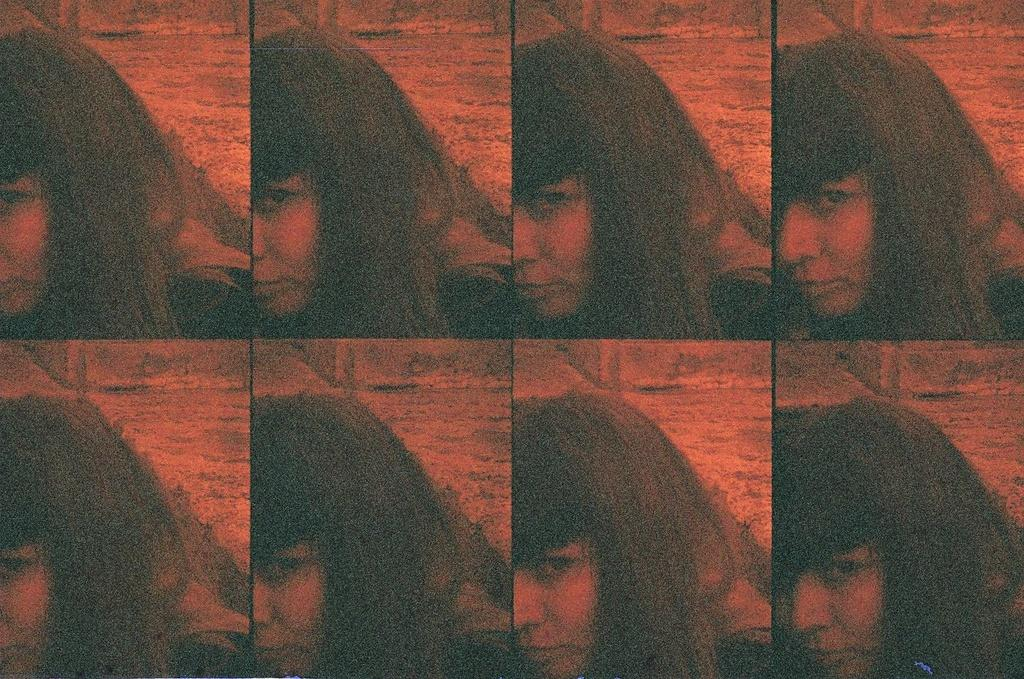Who is present in the image? There is a lady in the image. What can be seen in the background of the image? There is a wall in the background of the image. What type of plant is being used as a source of oil in the image? There is no plant or oil present in the image; it only features a lady and a wall in the background. 